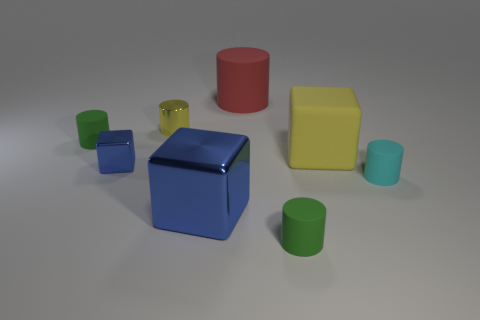The yellow matte cube has what size?
Offer a terse response. Large. How many other objects are there of the same color as the large cylinder?
Your answer should be very brief. 0. Does the large blue block right of the tiny blue shiny thing have the same material as the yellow cylinder?
Keep it short and to the point. Yes. Are there fewer cubes that are in front of the cyan cylinder than matte cylinders that are in front of the yellow rubber object?
Offer a very short reply. Yes. How many other objects are there of the same material as the big yellow cube?
Provide a succinct answer. 4. What material is the blue block that is the same size as the red matte thing?
Offer a terse response. Metal. Are there fewer green cylinders behind the yellow shiny cylinder than big gray cylinders?
Give a very brief answer. No. What is the shape of the rubber thing on the left side of the blue object in front of the blue object behind the big blue metallic thing?
Offer a terse response. Cylinder. What size is the shiny block right of the small shiny cylinder?
Provide a succinct answer. Large. There is a yellow object that is the same size as the cyan rubber cylinder; what shape is it?
Provide a succinct answer. Cylinder. 